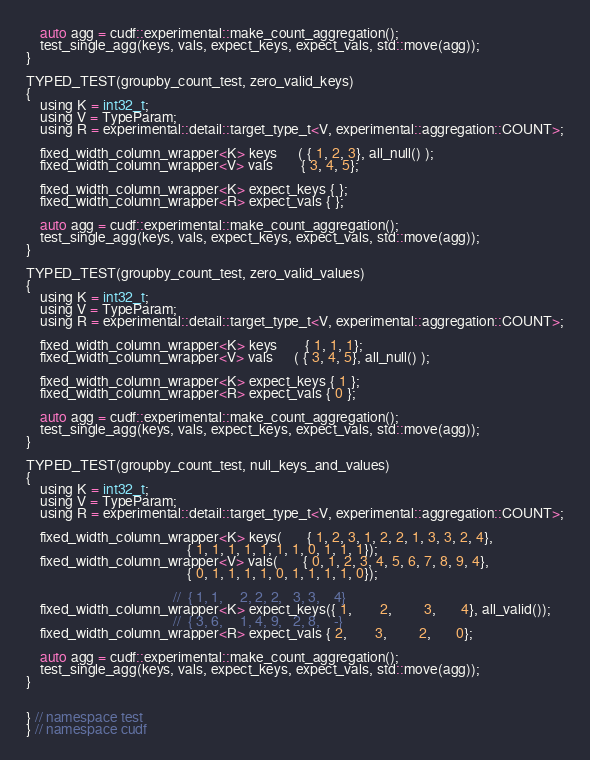Convert code to text. <code><loc_0><loc_0><loc_500><loc_500><_Cuda_>
    auto agg = cudf::experimental::make_count_aggregation();
    test_single_agg(keys, vals, expect_keys, expect_vals, std::move(agg));
}

TYPED_TEST(groupby_count_test, zero_valid_keys)
{
    using K = int32_t;
    using V = TypeParam;
    using R = experimental::detail::target_type_t<V, experimental::aggregation::COUNT>;

    fixed_width_column_wrapper<K> keys      ( { 1, 2, 3}, all_null() );
    fixed_width_column_wrapper<V> vals        { 3, 4, 5};

    fixed_width_column_wrapper<K> expect_keys { };
    fixed_width_column_wrapper<R> expect_vals { };

    auto agg = cudf::experimental::make_count_aggregation();
    test_single_agg(keys, vals, expect_keys, expect_vals, std::move(agg));
}

TYPED_TEST(groupby_count_test, zero_valid_values)
{
    using K = int32_t;
    using V = TypeParam;
    using R = experimental::detail::target_type_t<V, experimental::aggregation::COUNT>;

    fixed_width_column_wrapper<K> keys        { 1, 1, 1};
    fixed_width_column_wrapper<V> vals      ( { 3, 4, 5}, all_null() );

    fixed_width_column_wrapper<K> expect_keys { 1 };
    fixed_width_column_wrapper<R> expect_vals { 0 };

    auto agg = cudf::experimental::make_count_aggregation();
    test_single_agg(keys, vals, expect_keys, expect_vals, std::move(agg));
}

TYPED_TEST(groupby_count_test, null_keys_and_values)
{
    using K = int32_t;
    using V = TypeParam;
    using R = experimental::detail::target_type_t<V, experimental::aggregation::COUNT>;

    fixed_width_column_wrapper<K> keys(       { 1, 2, 3, 1, 2, 2, 1, 3, 3, 2, 4},
                                              { 1, 1, 1, 1, 1, 1, 1, 0, 1, 1, 1});
    fixed_width_column_wrapper<V> vals(       { 0, 1, 2, 3, 4, 5, 6, 7, 8, 9, 4},
                                              { 0, 1, 1, 1, 1, 0, 1, 1, 1, 1, 0});

                                          //  { 1, 1,     2, 2, 2,   3, 3,    4}
    fixed_width_column_wrapper<K> expect_keys({ 1,        2,         3,       4}, all_valid());
                                          //  { 3, 6,     1, 4, 9,   2, 8,    -}
    fixed_width_column_wrapper<R> expect_vals { 2,        3,         2,       0};

    auto agg = cudf::experimental::make_count_aggregation();
    test_single_agg(keys, vals, expect_keys, expect_vals, std::move(agg));
}


} // namespace test
} // namespace cudf
</code> 